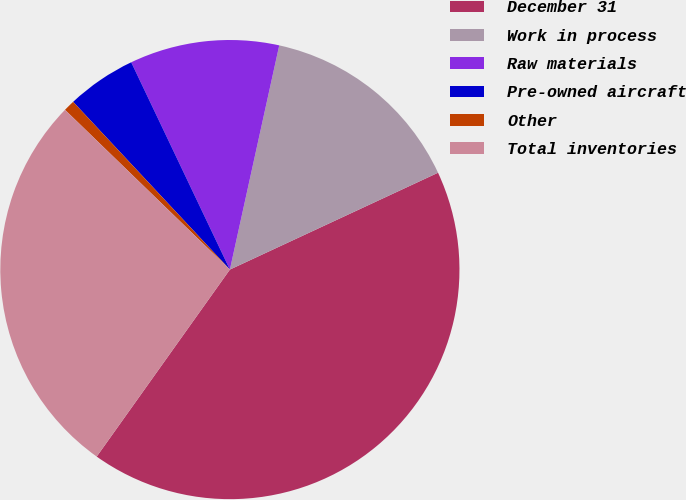Convert chart to OTSL. <chart><loc_0><loc_0><loc_500><loc_500><pie_chart><fcel>December 31<fcel>Work in process<fcel>Raw materials<fcel>Pre-owned aircraft<fcel>Other<fcel>Total inventories<nl><fcel>41.78%<fcel>14.62%<fcel>10.52%<fcel>4.89%<fcel>0.79%<fcel>27.4%<nl></chart> 